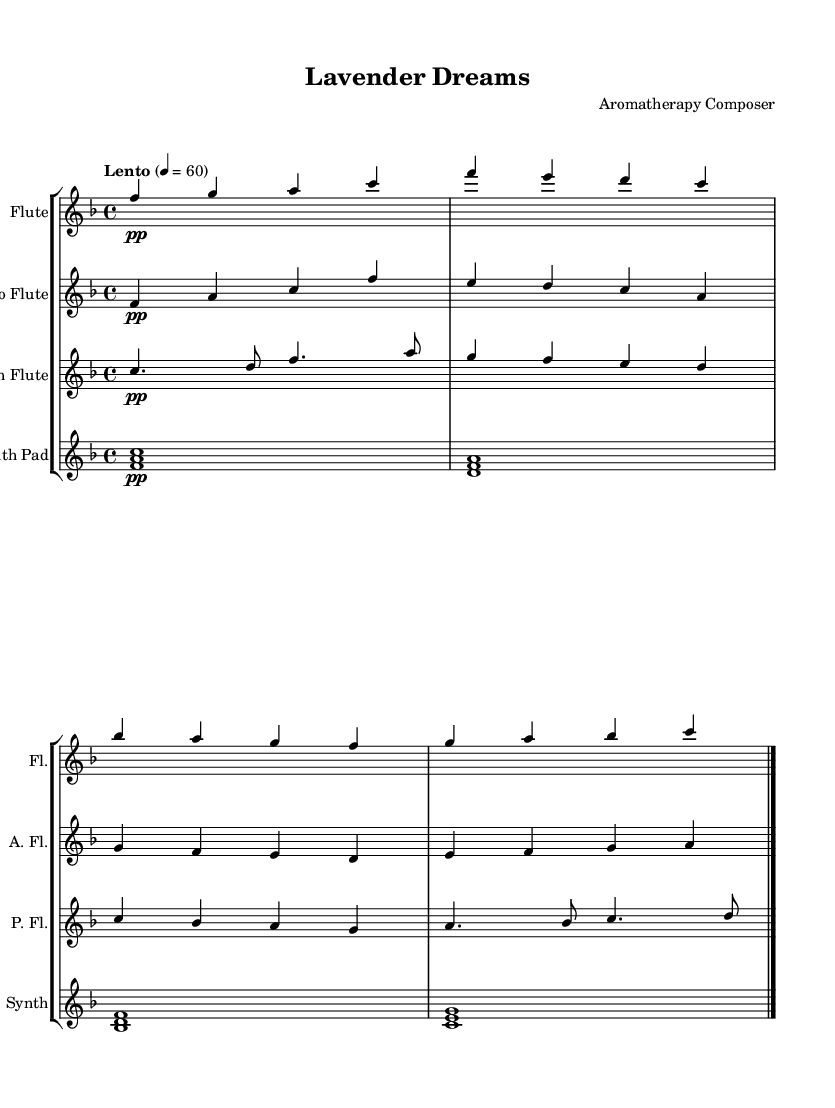What is the key signature of this music? The key signature is F major, which has one flat (B flat). This is indicated typically at the beginning of the staff with the flat symbol.
Answer: F major What is the time signature of this music? The time signature is 4/4, shown at the beginning of the score next to the key signature. This means there are four beats per measure, and the quarter note gets one beat.
Answer: 4/4 What tempo is marked for this piece? The tempo marking is "Lento," which indicates a slow tempo. This can be found at the beginning of the score and is usually followed by a metronome marking indicating the beats per minute.
Answer: Lento How many measures are in the flute part? The flute part has four measures, which can be counted by looking at the spacing and bar lines separating sections of music.
Answer: 4 Which instruments are used in this composition? The instruments used are Flute, Alto Flute, Pan Flute, and Synth Pad. Each of these is labeled at the beginning of their respective staves in the score.
Answer: Flute, Alto Flute, Pan Flute, Synth Pad What is the dynamic marking for all instruments in this score? The dynamic marking for all instruments is piano (p), which is indicated under the notation throughout the score. This means the music should be played softly.
Answer: piano Which instrument plays the lowest notes in the score? The Alto Flute plays the lowest notes in the score, as it is written in a lower register compared to the other instruments. This can be determined by visually inspecting the pitch of the notes on the staff.
Answer: Alto Flute 